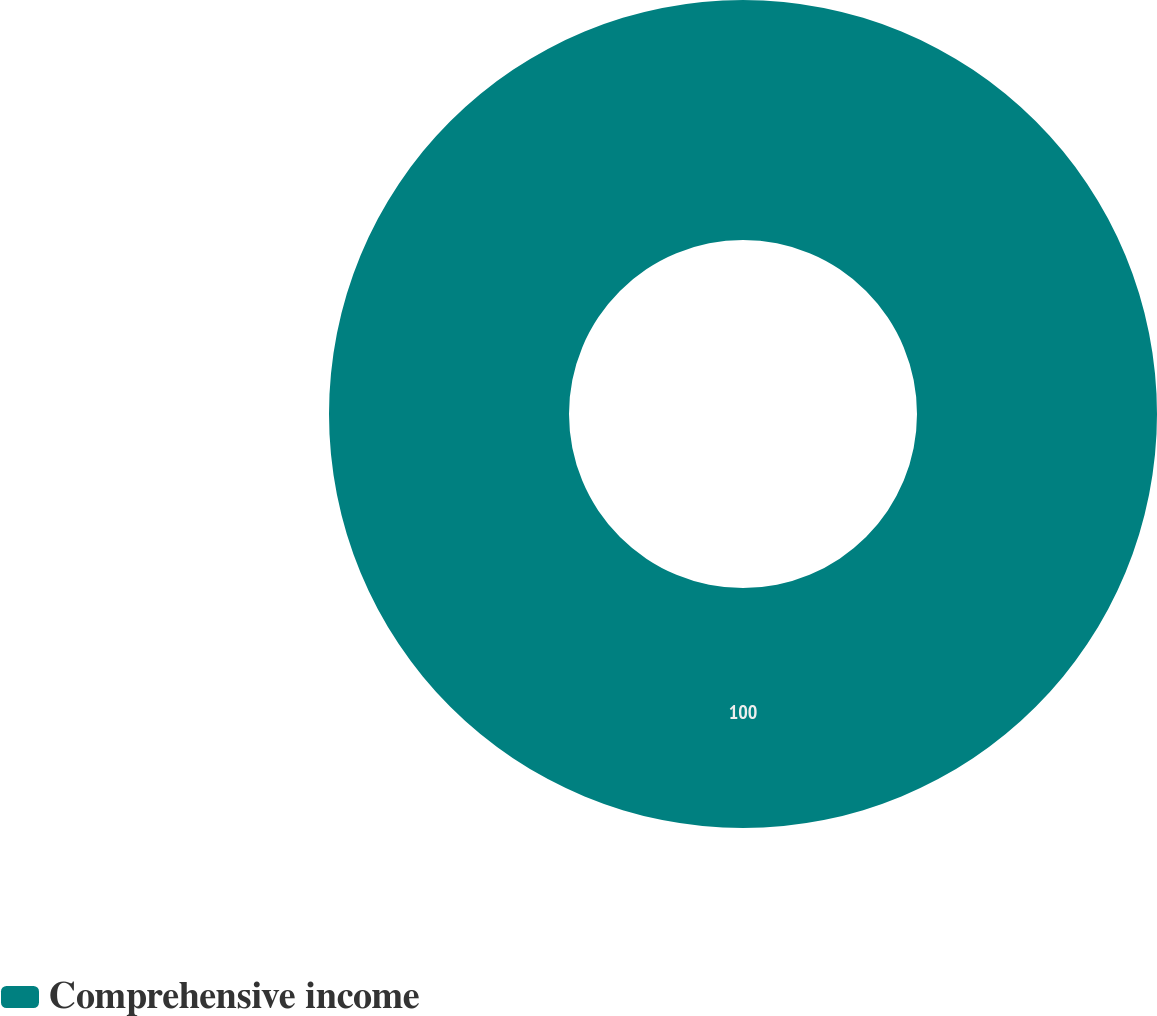Convert chart. <chart><loc_0><loc_0><loc_500><loc_500><pie_chart><fcel>Comprehensive income<nl><fcel>100.0%<nl></chart> 